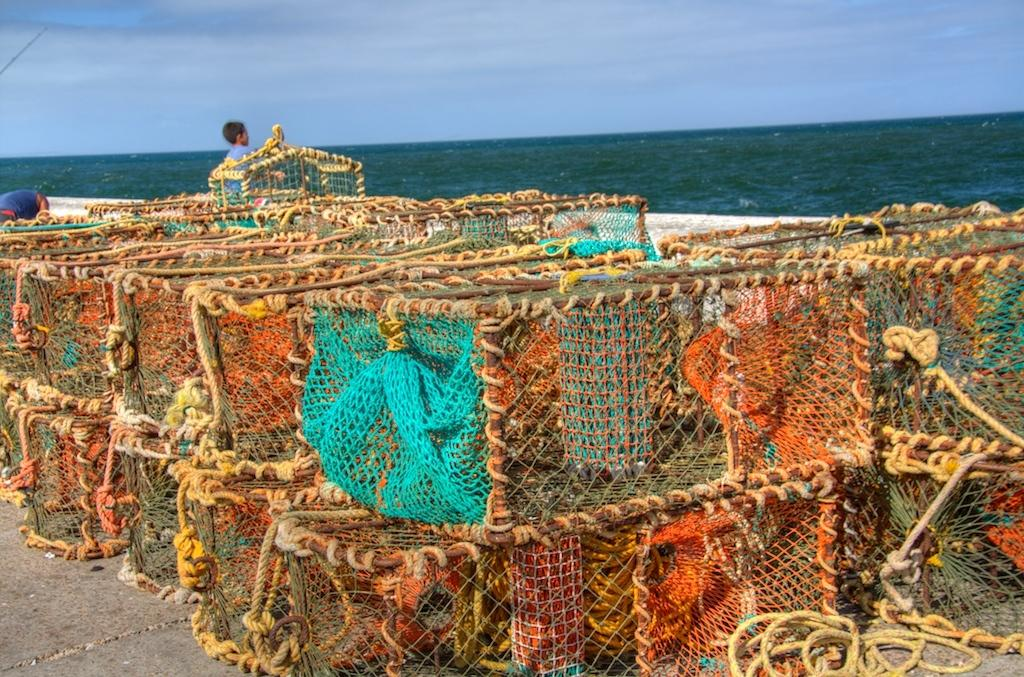What is the main subject of the image? The main subject of the image is boxed cakes covered with nets and ropes. Are there any people present in the image? Yes, there are two people behind the cakes. What can be seen in the background of the image? There is a sea visible in the background of the image. How many fingers can be seen holding the ropes in the image? There is no indication of fingers holding the ropes in the image, as the ropes are covering the cakes. Is there a dock visible in the image? There is no dock present in the image; only the sea is visible in the background. 